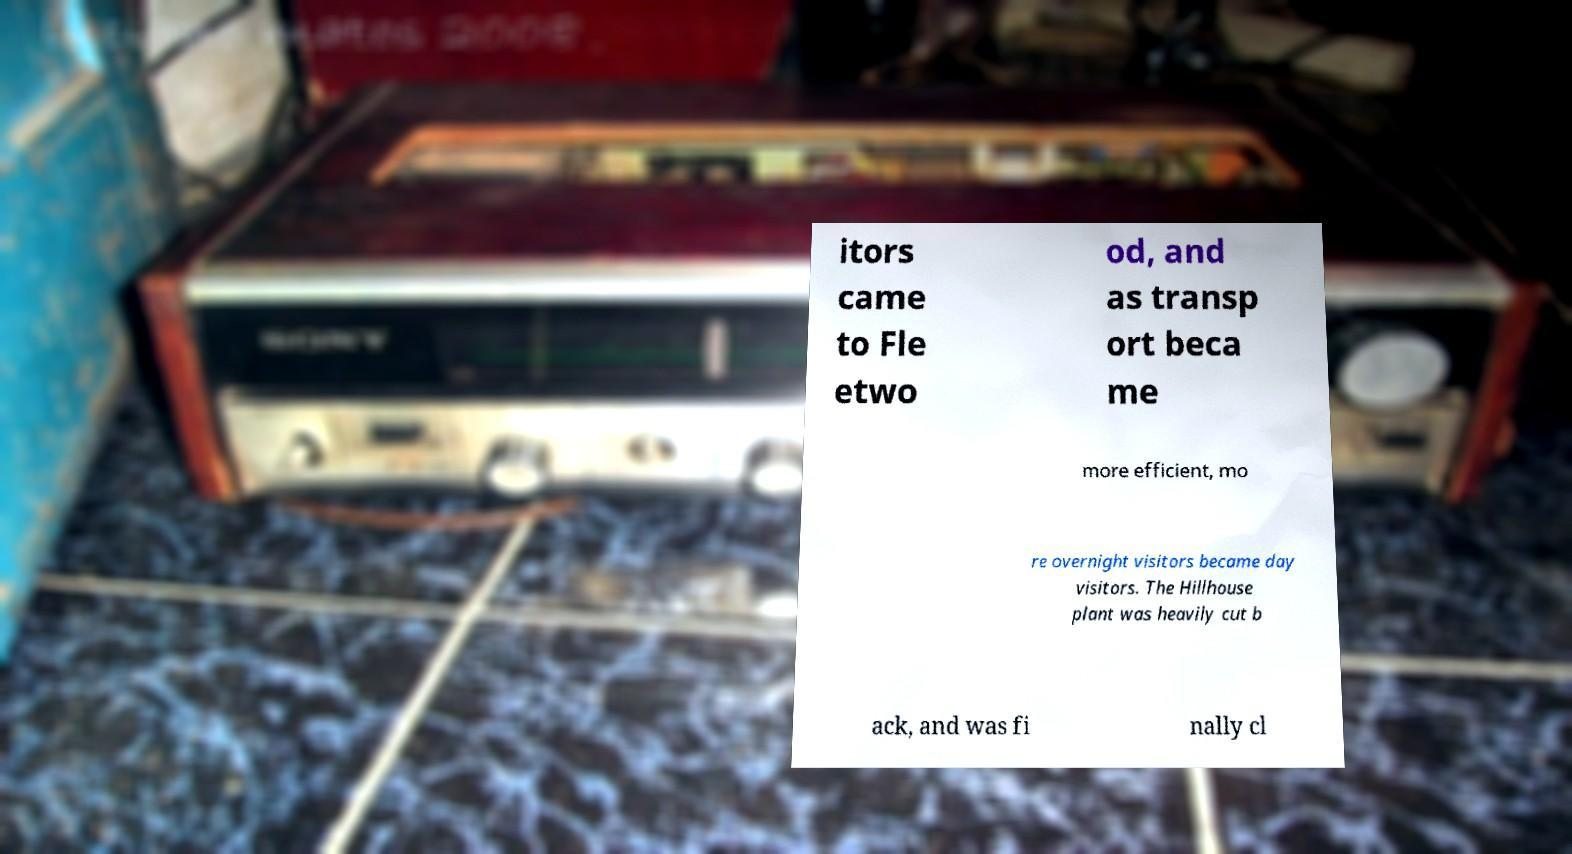Can you read and provide the text displayed in the image?This photo seems to have some interesting text. Can you extract and type it out for me? itors came to Fle etwo od, and as transp ort beca me more efficient, mo re overnight visitors became day visitors. The Hillhouse plant was heavily cut b ack, and was fi nally cl 